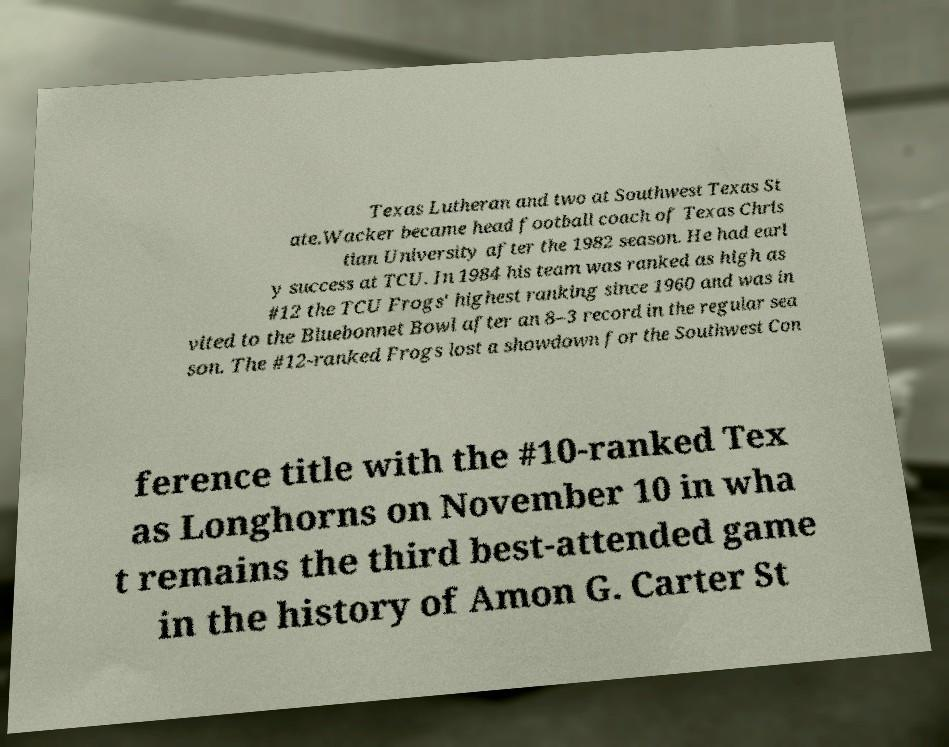Could you extract and type out the text from this image? Texas Lutheran and two at Southwest Texas St ate.Wacker became head football coach of Texas Chris tian University after the 1982 season. He had earl y success at TCU. In 1984 his team was ranked as high as #12 the TCU Frogs' highest ranking since 1960 and was in vited to the Bluebonnet Bowl after an 8–3 record in the regular sea son. The #12-ranked Frogs lost a showdown for the Southwest Con ference title with the #10-ranked Tex as Longhorns on November 10 in wha t remains the third best-attended game in the history of Amon G. Carter St 